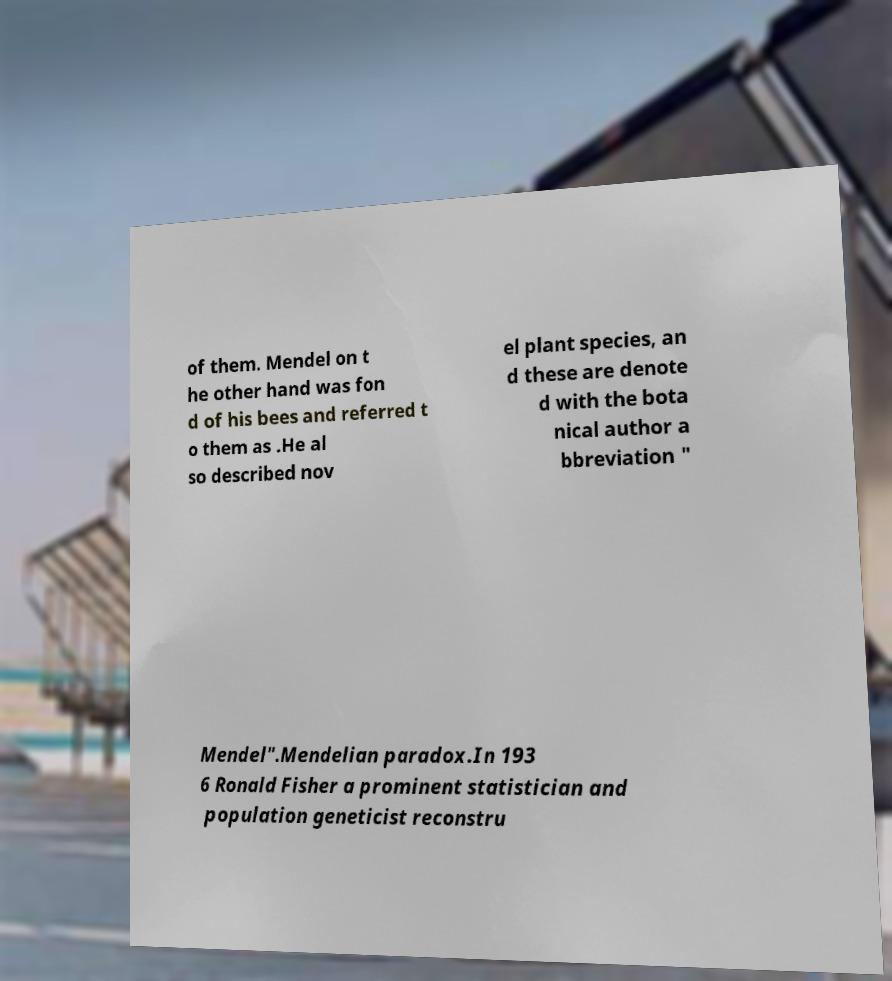Could you extract and type out the text from this image? of them. Mendel on t he other hand was fon d of his bees and referred t o them as .He al so described nov el plant species, an d these are denote d with the bota nical author a bbreviation " Mendel".Mendelian paradox.In 193 6 Ronald Fisher a prominent statistician and population geneticist reconstru 